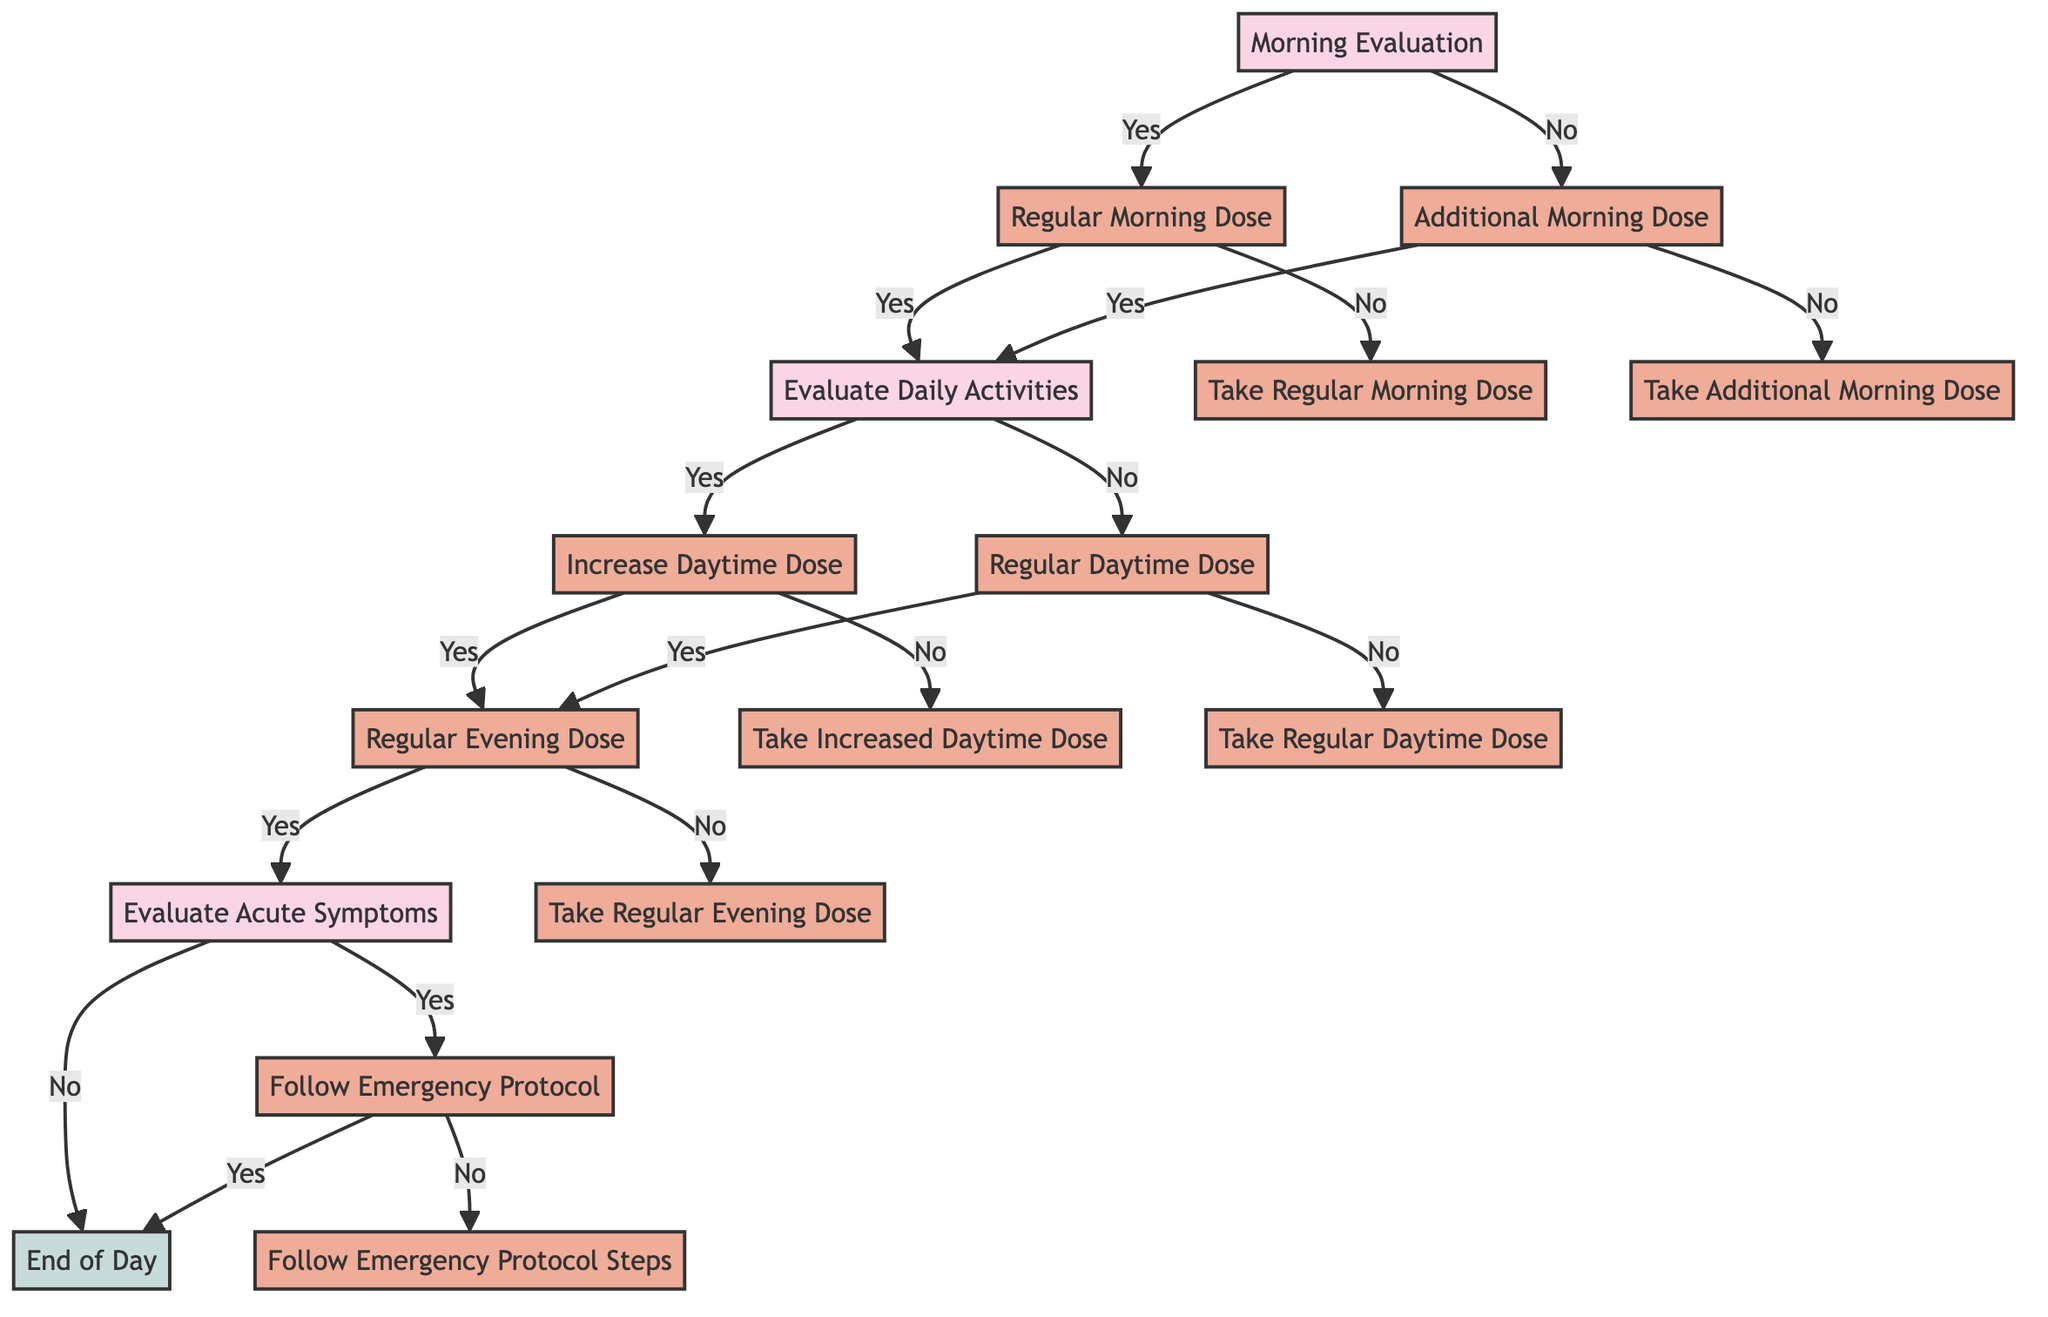What is the first decision point in the diagram? The diagram starts with the "Morning Evaluation" node, where the first question is asked to evaluate how the person feels in the morning.
Answer: Morning Evaluation How many options are available after the "Regular Morning Dose" node? From the "Regular Morning Dose" node, there are two options: one for taking the dose (Yes) and one for not taking it (No), making a total of two options.
Answer: 2 What happens if you answer "No" to the "Evaluate Daily Activities" question? If you answer "No" to "Evaluate Daily Activities," you proceed to "Regular Daytime Dose," indicating that no increase in the dose is necessary for the day’s activities.
Answer: Regular Daytime Dose What is the outcome if acute symptoms are experienced after the evening dose? If acute symptoms are experienced after taking the evening dose, the flow goes to "Follow Emergency Protocol," meaning immediate action must be taken to manage these symptoms.
Answer: Follow Emergency Protocol What does the path look like if you feel well-rested in the morning? If you feel well-rested in the morning, you follow the path from "Morning Evaluation" to "Regular Morning Dose," then proceed to "Evaluate Daily Activities," leading to a further evaluation of daily requirements.
Answer: Regular Morning Dose What is the last decision point in the flow? The last decision point in the flow is "Follow Emergency Protocol," which determines if the emergency steps have been followed after experiencing acute symptoms.
Answer: Follow Emergency Protocol 